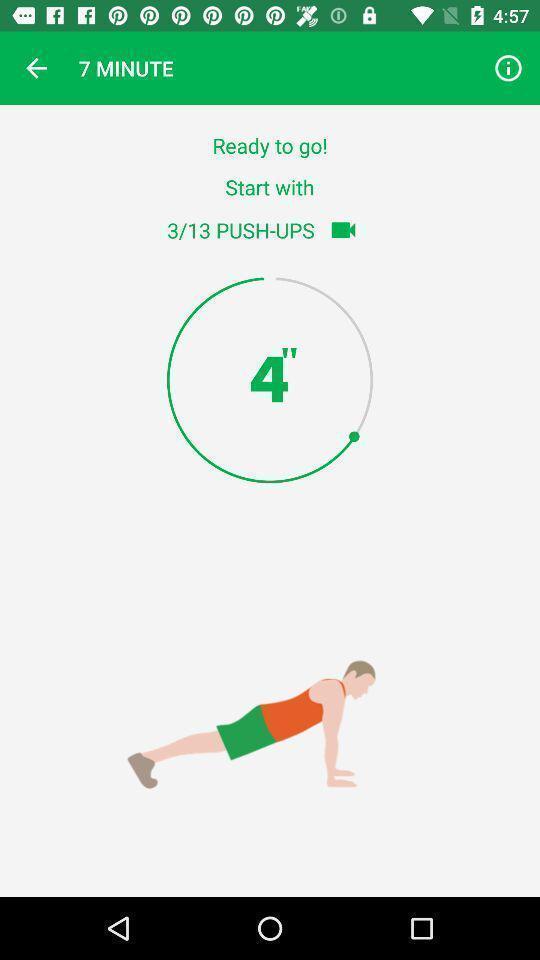Explain what's happening in this screen capture. Workout timer displayed for a fitness training app. 